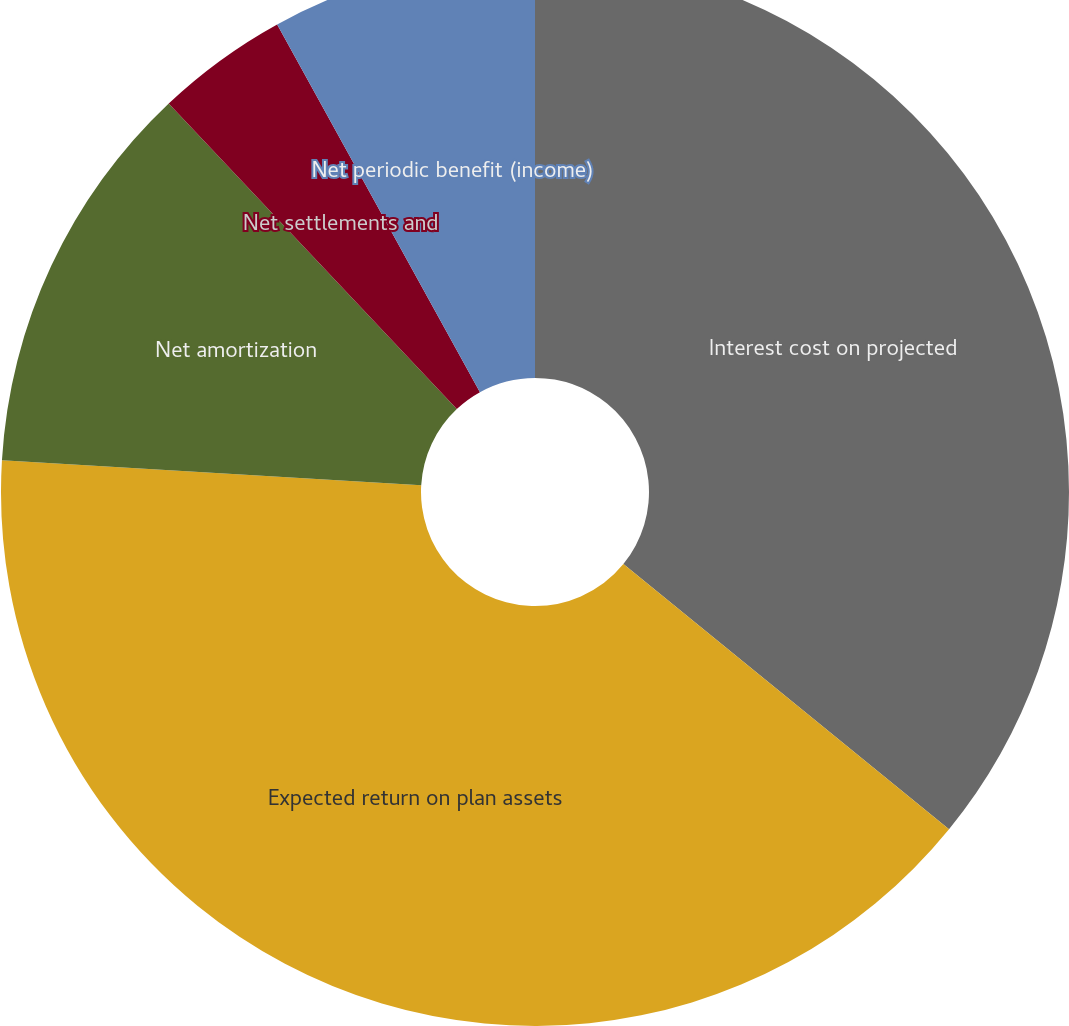Convert chart to OTSL. <chart><loc_0><loc_0><loc_500><loc_500><pie_chart><fcel>Service cost benefits earned<fcel>Interest cost on projected<fcel>Expected return on plan assets<fcel>Net amortization<fcel>Net settlements and<fcel>Net periodic benefit (income)<nl><fcel>0.0%<fcel>35.88%<fcel>40.07%<fcel>12.02%<fcel>4.01%<fcel>8.02%<nl></chart> 